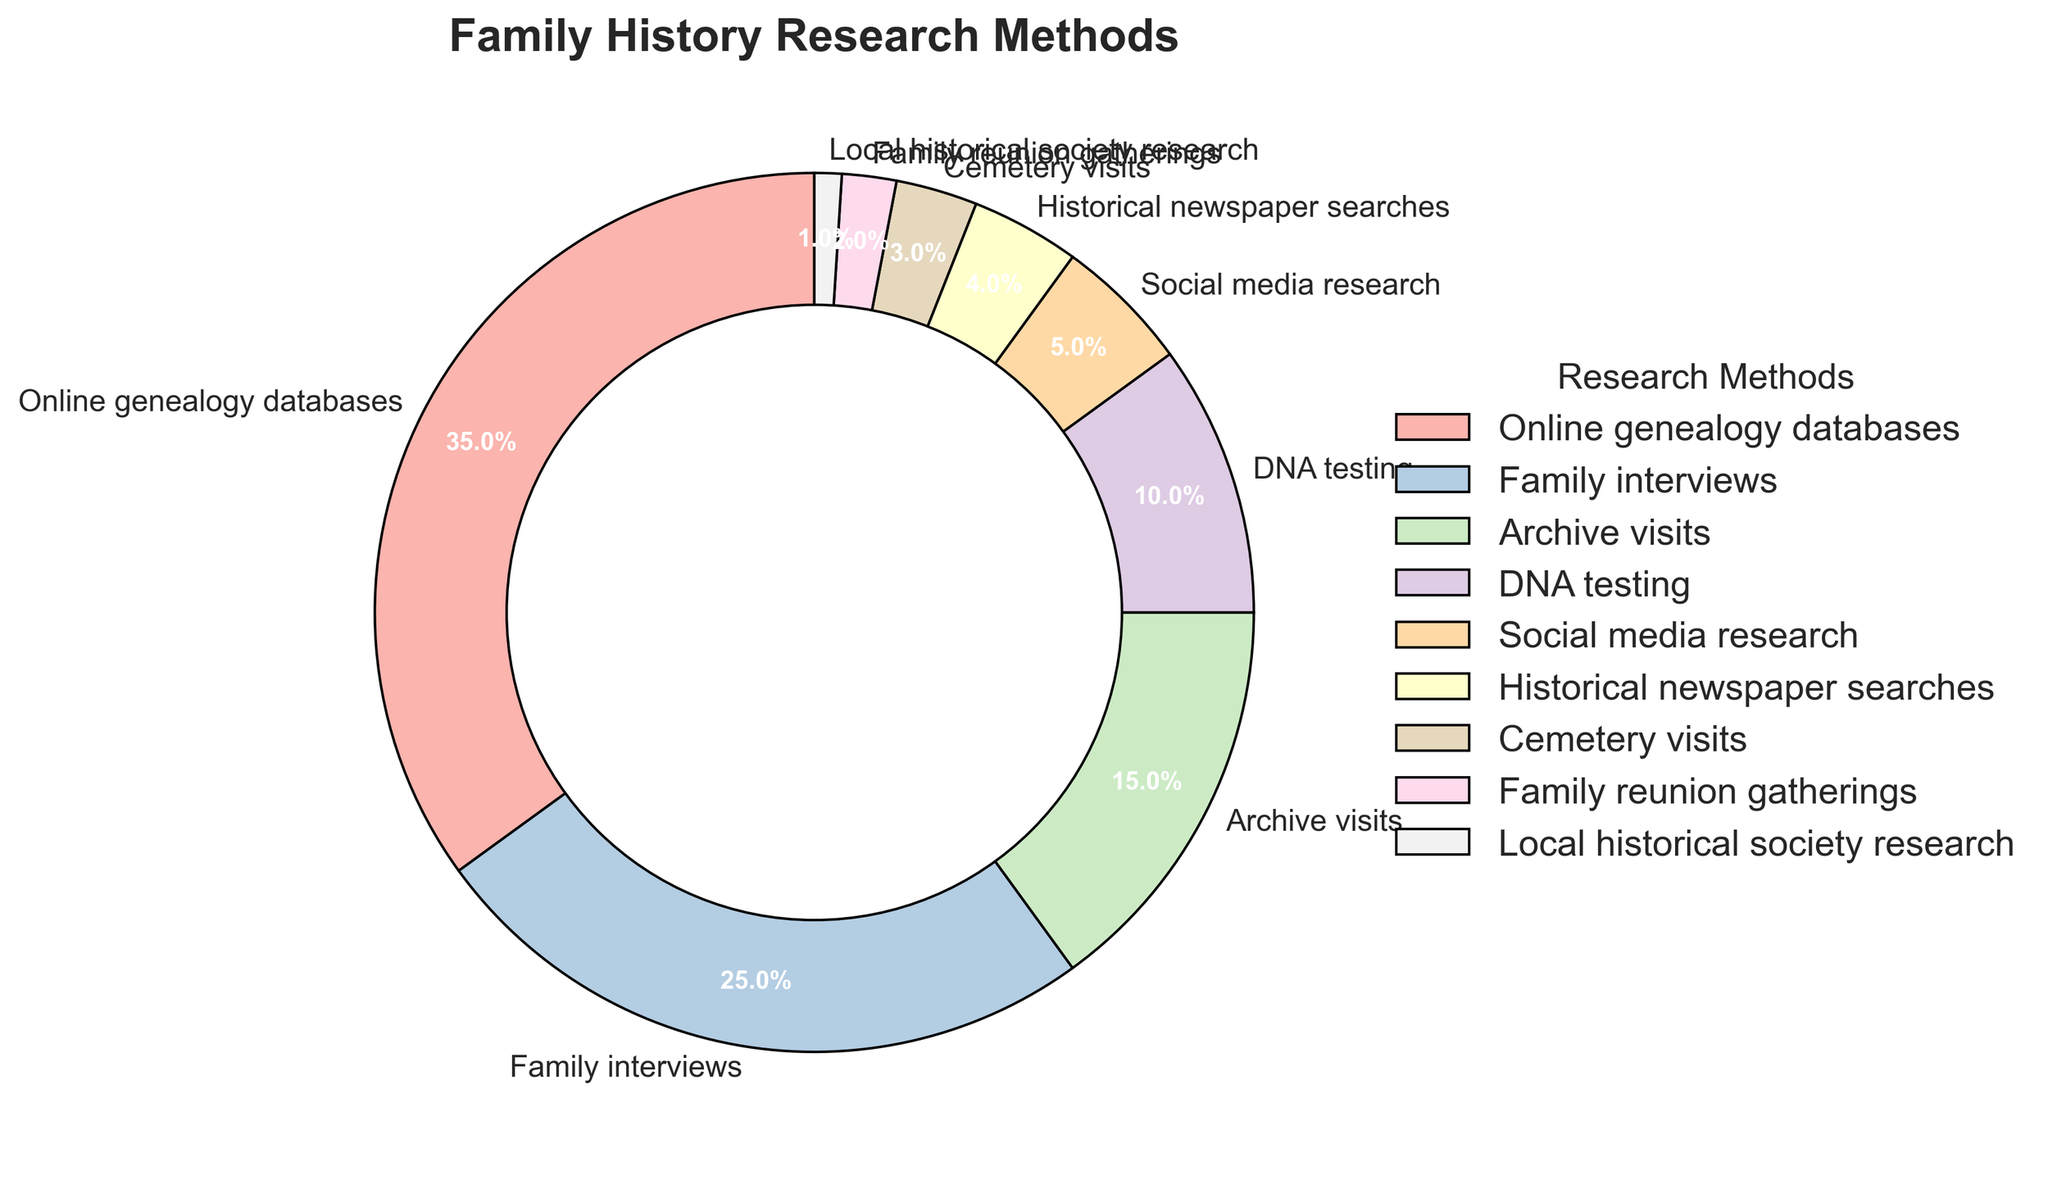What's the total percentage for traditional methods like family interviews and archive visits combined? To find the combined percentage, add the percentage for family interviews (25%) and archive visits (15%). Therefore, 25% + 15% = 40%.
Answer: 40% Which research method is used more, DNA testing or social media research? By comparing their percentages, DNA testing has 10% whereas social media research has 5%. Thus, DNA testing is used more.
Answer: DNA testing How much less time is spent on family reunion gatherings compared to social media research? To find the difference, subtract the percentage of family reunion gatherings (2%) from social media research (5%), resulting in 5% - 2% = 3%.
Answer: 3% What's the percentage difference between the top method and the least used method? The top method is online genealogy databases with 35% and the least used method is local historical society research with 1%. The difference is 35% - 1% = 34%.
Answer: 34% Are archive visits or cemetery visits used less in family history research? Archive visits are utilized 15% of the time, while cemetery visits are only 3%. Therefore, cemetery visits are used less.
Answer: Cemetery visits How many methods have a percentage of use lower than 10%? By examining the figure, social media research (5%), historical newspaper searches (4%), cemetery visits (3%), family reunion gatherings (2%), and local historical society research (1%) are all below 10%. That makes a total of 5 methods.
Answer: 5 What's the ratio of time spent on family interviews compared to DNA testing? Family interviews take up 25% whereas DNA testing is at 10%. The ratio is 25:10, which can be simplified to 2.5:1.
Answer: 2.5:1 Which method accounts for a quarter of the total time spent? According to the chart, family interviews account for 25% of the time, which is a quarter of the total time.
Answer: Family interviews Is more or less time spent on historical newspaper searches than on social media research? Historical newspaper searches take up 4%, whereas social media research takes up 5%. Thus, more time is spent on social media research.
Answer: More What's the combined percentage for all methods categorized under technology-based research (online databases, social media research, and DNA testing)? Adding the percentages of online genealogy databases (35%), social media research (5%), and DNA testing (10%), we get 35% + 5% + 10% = 50%.
Answer: 50% 